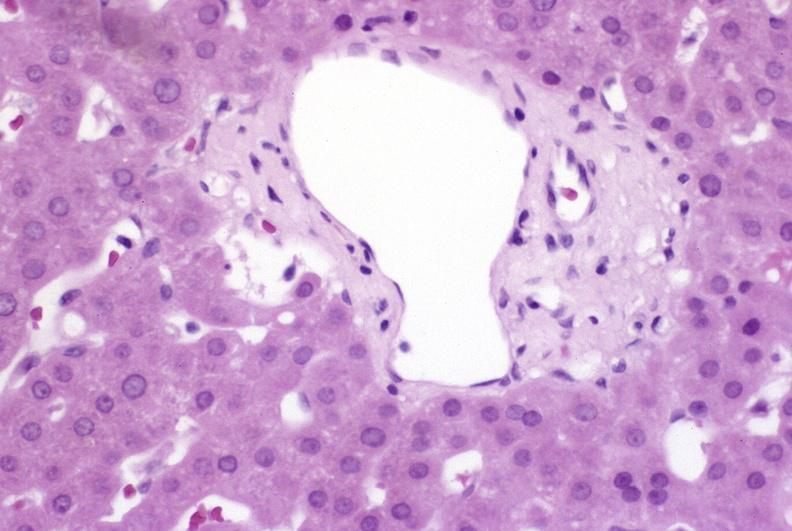s liver present?
Answer the question using a single word or phrase. Yes 